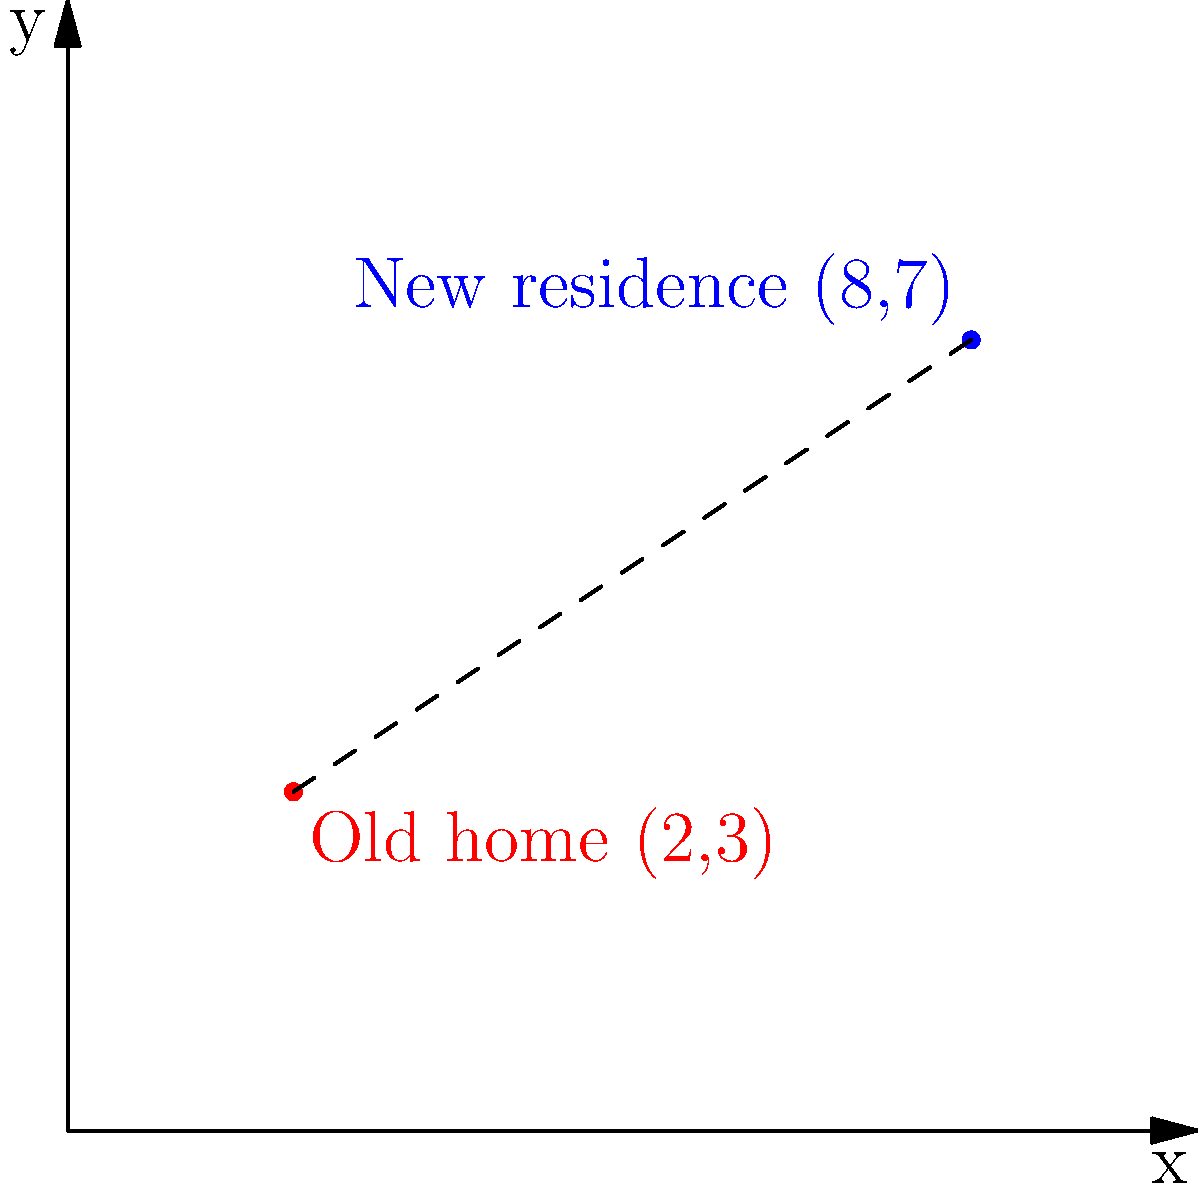A refugee family has relocated to a new residence with the help of a supportive couple. On a coordinate plane, their old home is represented by the point (2,3), and their new residence is at (8,7). Calculate the distance between their old home and new residence to the nearest tenth of a unit. To find the distance between two points on a coordinate plane, we can use the distance formula:

$$ d = \sqrt{(x_2 - x_1)^2 + (y_2 - y_1)^2} $$

Where $(x_1, y_1)$ is the coordinate of the old home and $(x_2, y_2)$ is the coordinate of the new residence.

Step 1: Identify the coordinates
Old home: $(x_1, y_1) = (2, 3)$
New residence: $(x_2, y_2) = (8, 7)$

Step 2: Plug the values into the distance formula
$$ d = \sqrt{(8 - 2)^2 + (7 - 3)^2} $$

Step 3: Simplify the expressions inside the parentheses
$$ d = \sqrt{6^2 + 4^2} $$

Step 4: Calculate the squares
$$ d = \sqrt{36 + 16} $$

Step 5: Add the values under the square root
$$ d = \sqrt{52} $$

Step 6: Simplify the square root
$$ d \approx 7.2111 $$

Step 7: Round to the nearest tenth
$$ d \approx 7.2 $$

Therefore, the distance between the old home and new residence is approximately 7.2 units.
Answer: 7.2 units 